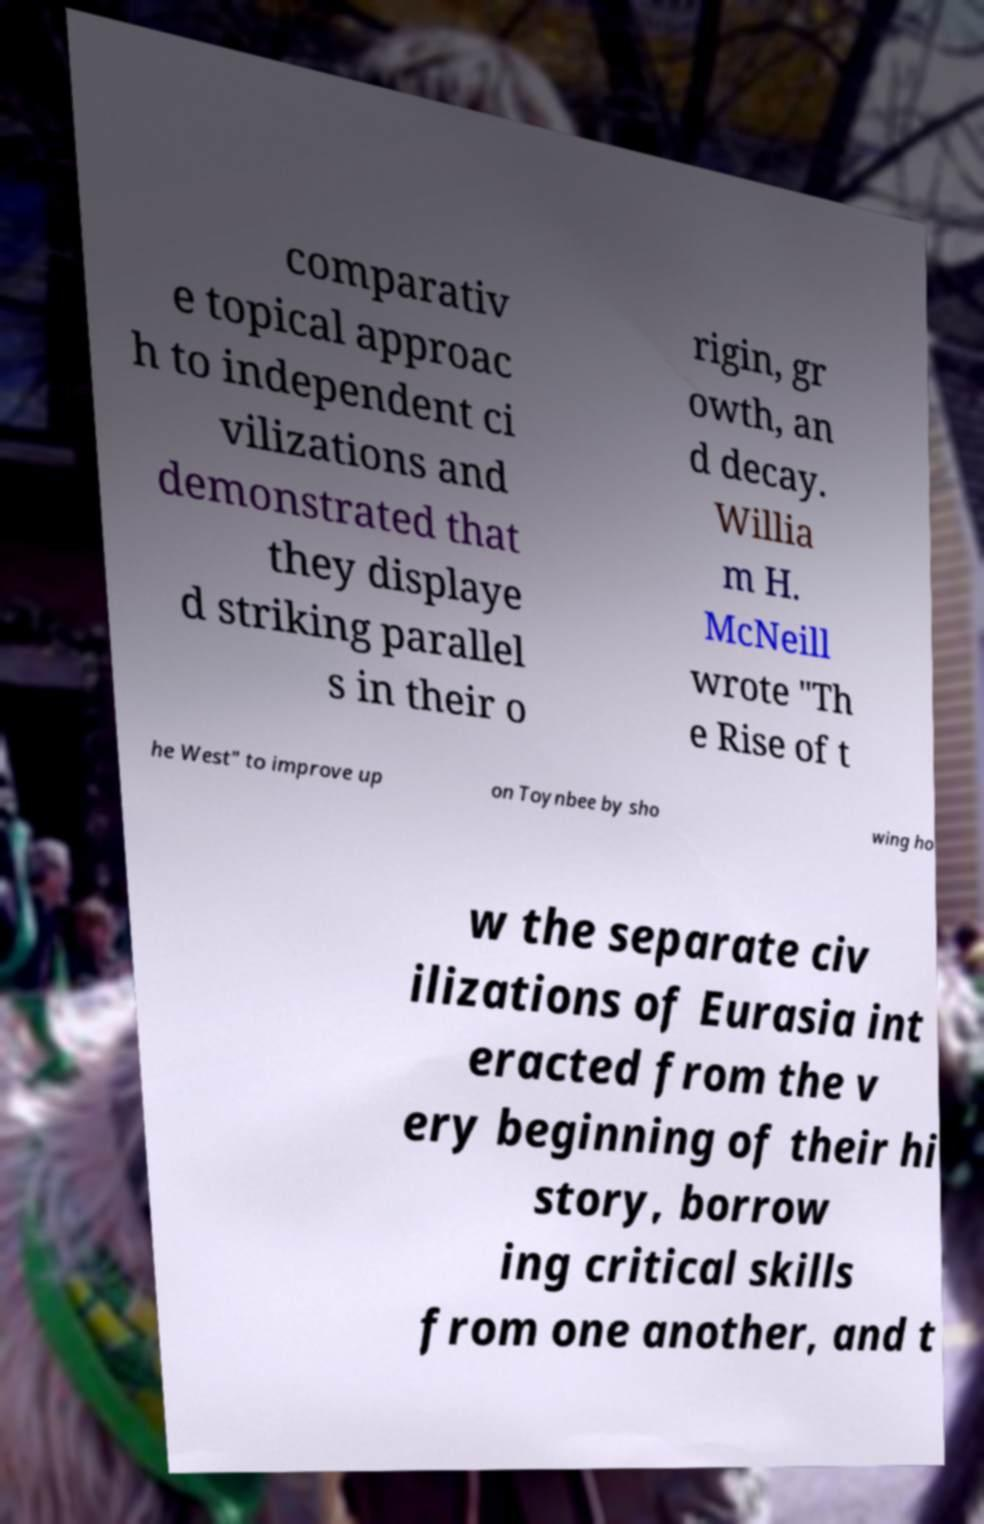Please identify and transcribe the text found in this image. comparativ e topical approac h to independent ci vilizations and demonstrated that they displaye d striking parallel s in their o rigin, gr owth, an d decay. Willia m H. McNeill wrote "Th e Rise of t he West" to improve up on Toynbee by sho wing ho w the separate civ ilizations of Eurasia int eracted from the v ery beginning of their hi story, borrow ing critical skills from one another, and t 